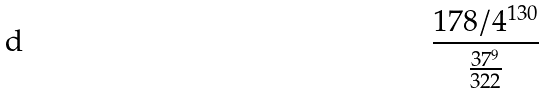<formula> <loc_0><loc_0><loc_500><loc_500>\frac { 1 7 8 / 4 ^ { 1 3 0 } } { \frac { 3 7 ^ { 9 } } { 3 2 2 } }</formula> 